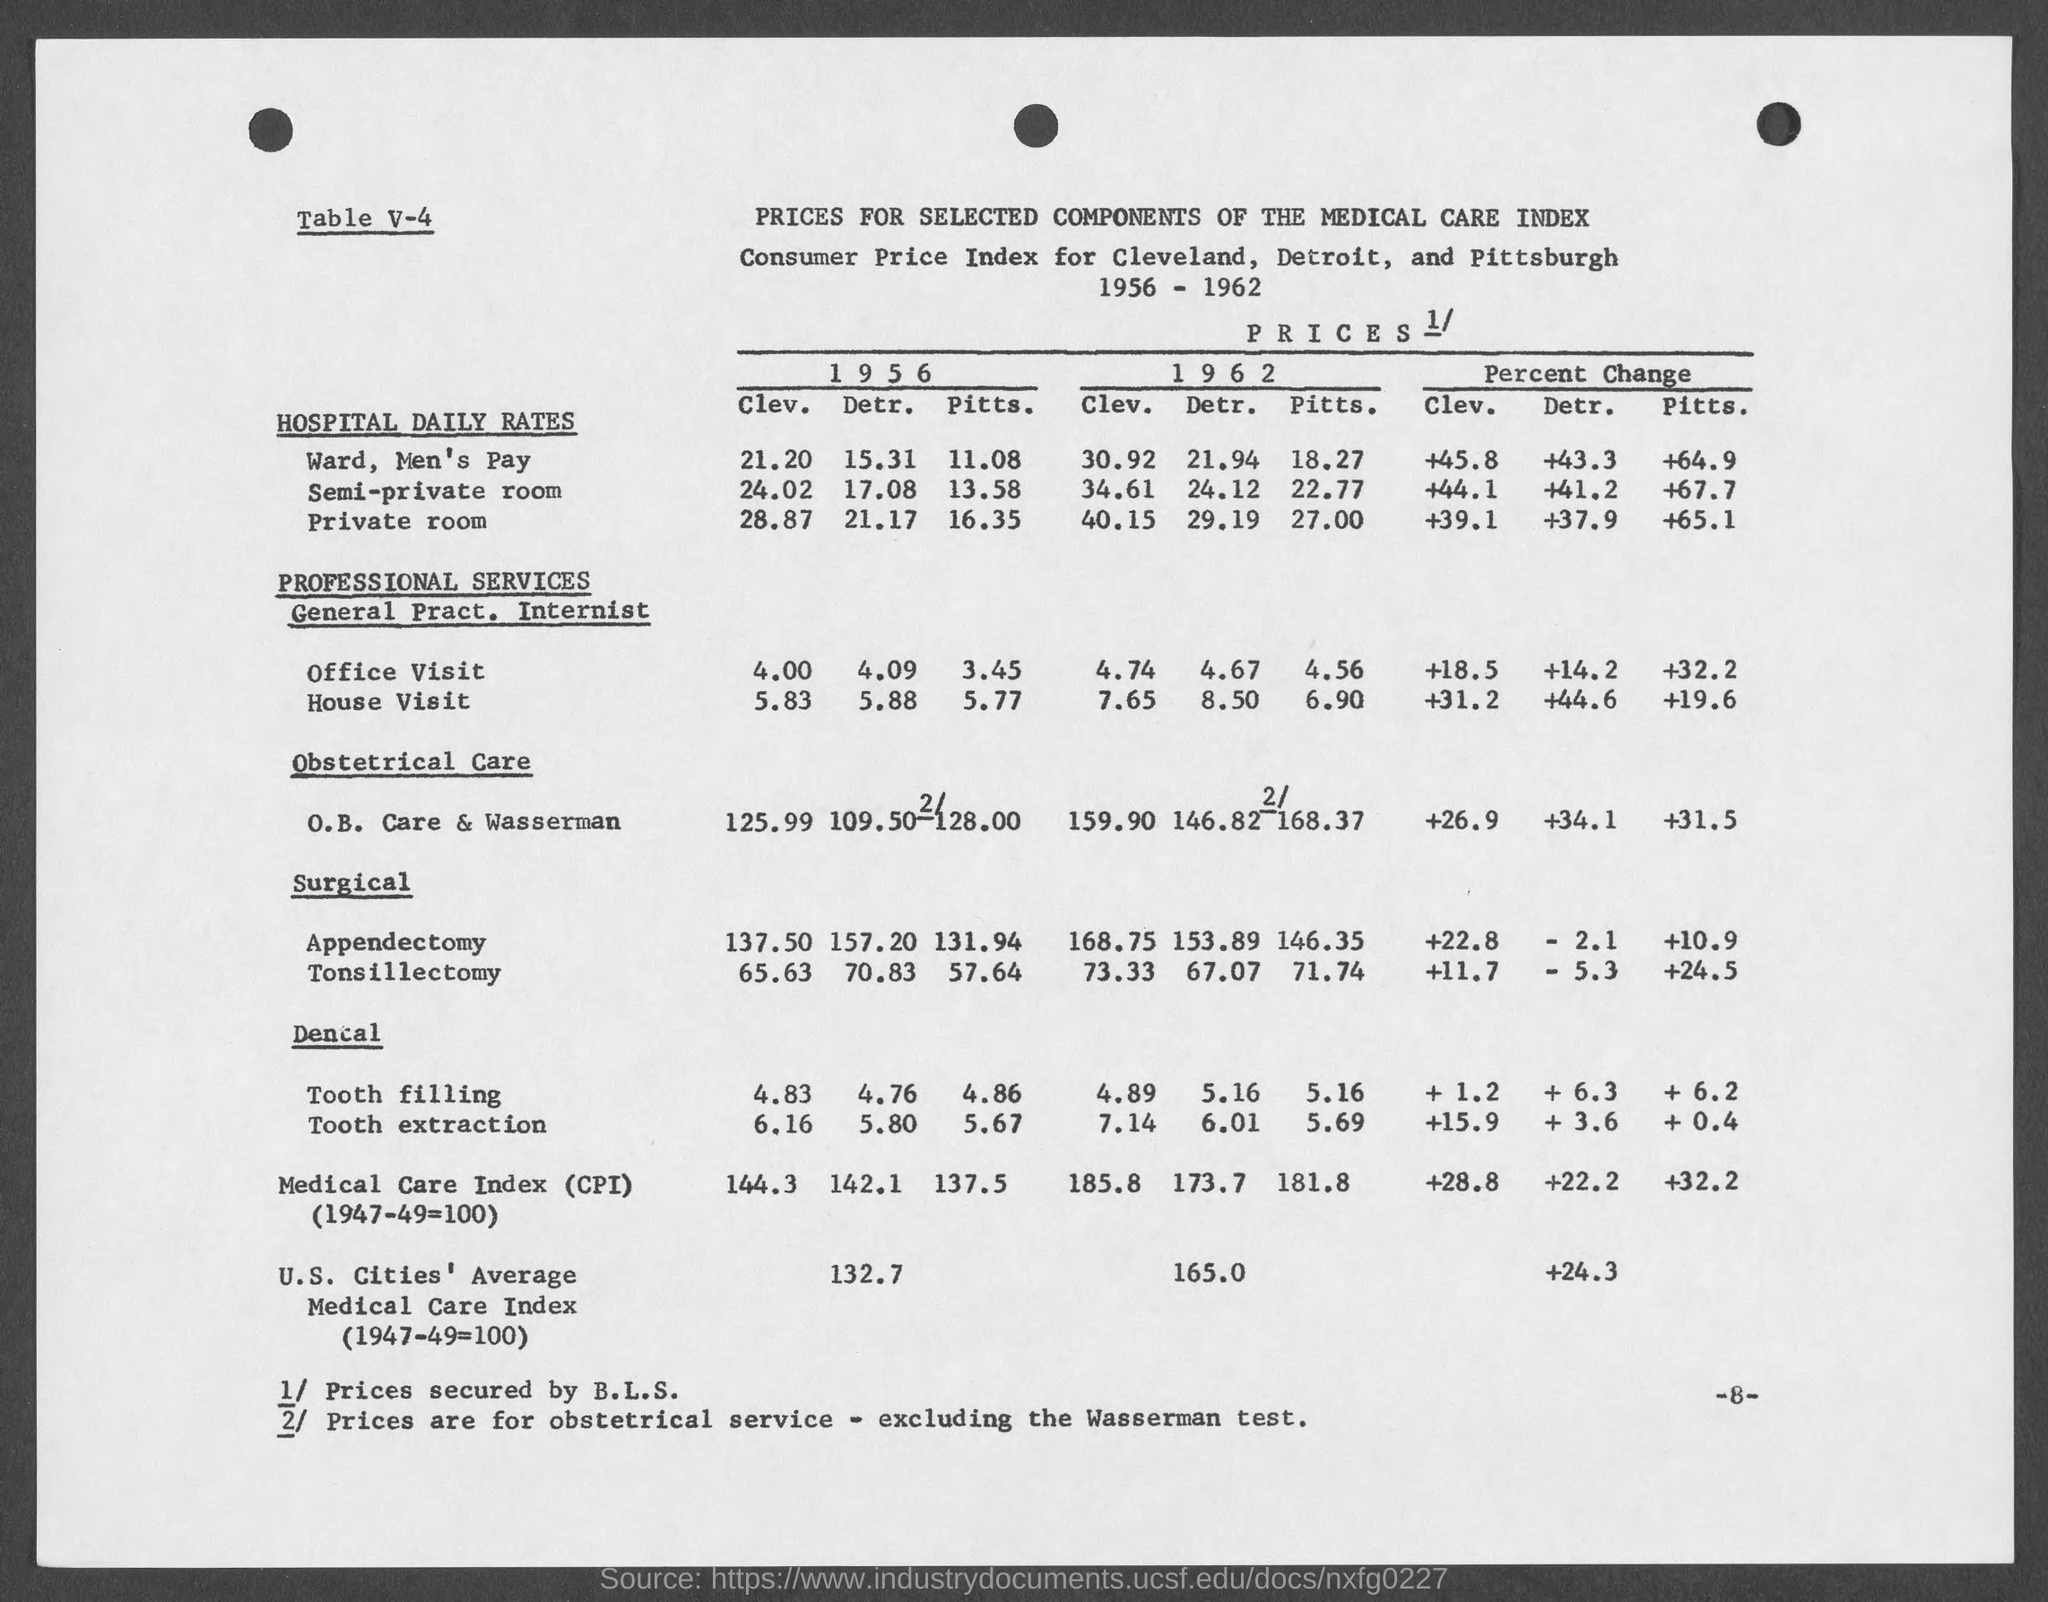Specify some key components in this picture. The bottom right number on the page is -8. 